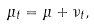<formula> <loc_0><loc_0><loc_500><loc_500>\mu _ { t } = \mu + \nu _ { t } ,</formula> 